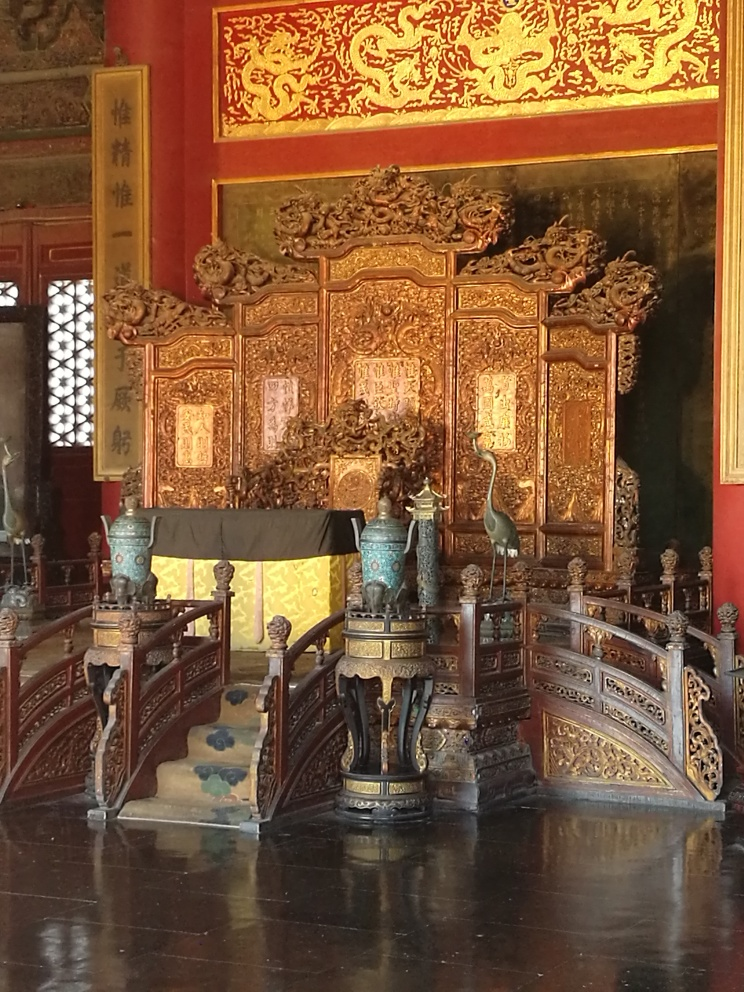What might the purpose of this room be? Judging from the grandeur of the throne and the ornamental details, this room was likely used for important ceremonies or as the imperial audience hall where the emperor would receive dignitaries, conduct court affairs, or celebrate significant events. Can you describe what a ceremony here might have been like? A ceremony would have been a formal and solemn occasion, with the emperor seated upon the throne, surrounded by court officials in hierarchical order. It could involve rituals such as kowtowing, the presentation of gifts, and the reading of edicts. The ceremony would be steeped in tradition, signifying the divine and earthly power vested in the emperor. 